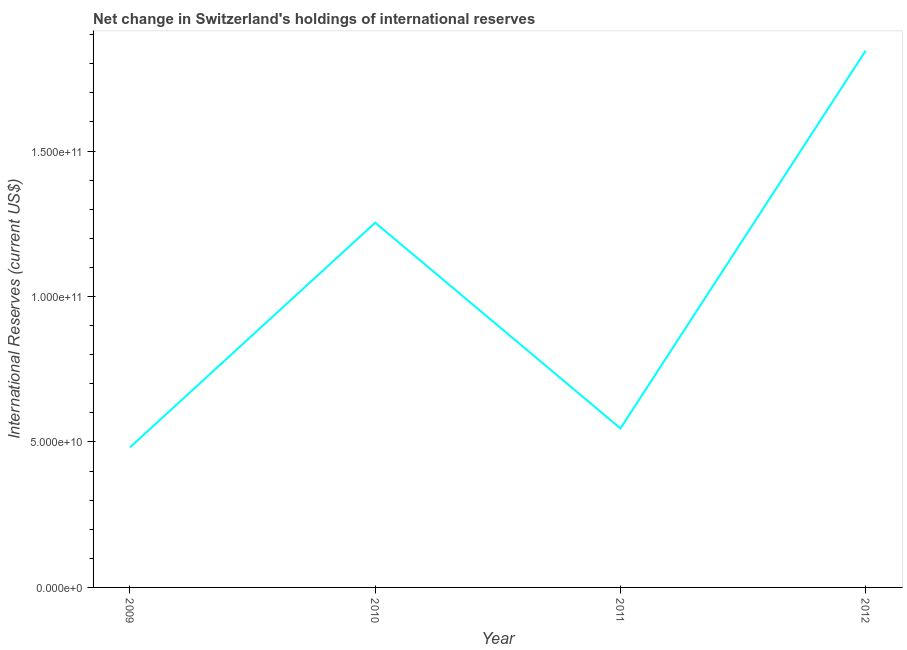What is the reserves and related items in 2011?
Ensure brevity in your answer.  5.47e+1. Across all years, what is the maximum reserves and related items?
Provide a succinct answer. 1.85e+11. Across all years, what is the minimum reserves and related items?
Ensure brevity in your answer.  4.81e+1. In which year was the reserves and related items maximum?
Your answer should be very brief. 2012. What is the sum of the reserves and related items?
Give a very brief answer. 4.13e+11. What is the difference between the reserves and related items in 2010 and 2011?
Make the answer very short. 7.07e+1. What is the average reserves and related items per year?
Your answer should be compact. 1.03e+11. What is the median reserves and related items?
Keep it short and to the point. 9.00e+1. Do a majority of the years between 2010 and 2011 (inclusive) have reserves and related items greater than 90000000000 US$?
Keep it short and to the point. No. What is the ratio of the reserves and related items in 2011 to that in 2012?
Ensure brevity in your answer.  0.3. Is the reserves and related items in 2011 less than that in 2012?
Provide a succinct answer. Yes. What is the difference between the highest and the second highest reserves and related items?
Offer a very short reply. 5.91e+1. Is the sum of the reserves and related items in 2009 and 2012 greater than the maximum reserves and related items across all years?
Offer a terse response. Yes. What is the difference between the highest and the lowest reserves and related items?
Give a very brief answer. 1.36e+11. Are the values on the major ticks of Y-axis written in scientific E-notation?
Your answer should be compact. Yes. Does the graph contain any zero values?
Offer a very short reply. No. What is the title of the graph?
Ensure brevity in your answer.  Net change in Switzerland's holdings of international reserves. What is the label or title of the X-axis?
Provide a short and direct response. Year. What is the label or title of the Y-axis?
Your answer should be compact. International Reserves (current US$). What is the International Reserves (current US$) of 2009?
Ensure brevity in your answer.  4.81e+1. What is the International Reserves (current US$) of 2010?
Offer a terse response. 1.25e+11. What is the International Reserves (current US$) in 2011?
Provide a succinct answer. 5.47e+1. What is the International Reserves (current US$) in 2012?
Make the answer very short. 1.85e+11. What is the difference between the International Reserves (current US$) in 2009 and 2010?
Ensure brevity in your answer.  -7.72e+1. What is the difference between the International Reserves (current US$) in 2009 and 2011?
Keep it short and to the point. -6.53e+09. What is the difference between the International Reserves (current US$) in 2009 and 2012?
Provide a succinct answer. -1.36e+11. What is the difference between the International Reserves (current US$) in 2010 and 2011?
Your answer should be very brief. 7.07e+1. What is the difference between the International Reserves (current US$) in 2010 and 2012?
Your answer should be very brief. -5.91e+1. What is the difference between the International Reserves (current US$) in 2011 and 2012?
Offer a very short reply. -1.30e+11. What is the ratio of the International Reserves (current US$) in 2009 to that in 2010?
Offer a very short reply. 0.38. What is the ratio of the International Reserves (current US$) in 2009 to that in 2011?
Give a very brief answer. 0.88. What is the ratio of the International Reserves (current US$) in 2009 to that in 2012?
Offer a terse response. 0.26. What is the ratio of the International Reserves (current US$) in 2010 to that in 2011?
Your answer should be very brief. 2.29. What is the ratio of the International Reserves (current US$) in 2010 to that in 2012?
Your response must be concise. 0.68. What is the ratio of the International Reserves (current US$) in 2011 to that in 2012?
Make the answer very short. 0.3. 